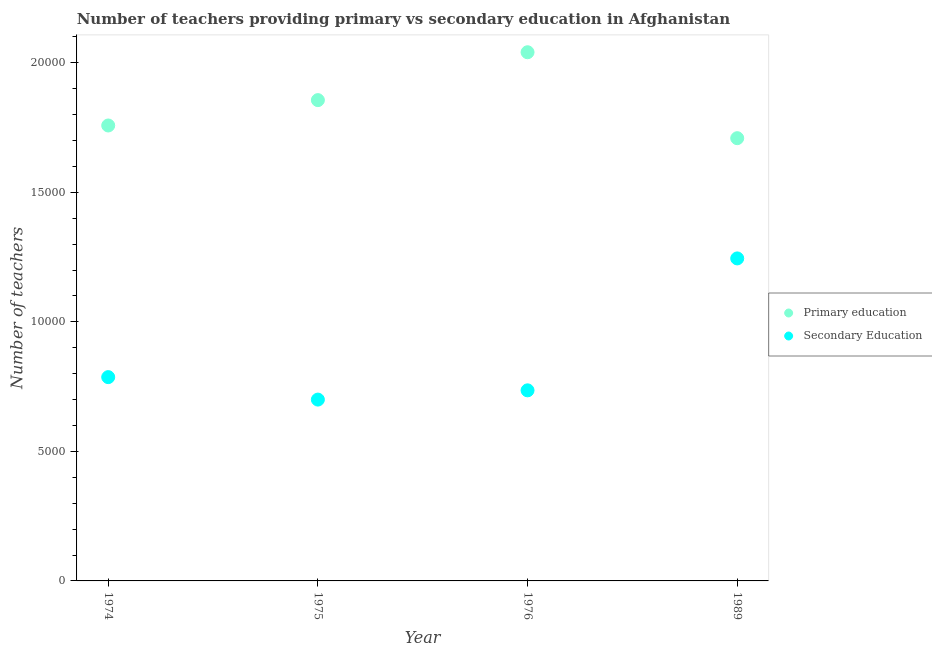Is the number of dotlines equal to the number of legend labels?
Ensure brevity in your answer.  Yes. What is the number of primary teachers in 1975?
Your answer should be very brief. 1.86e+04. Across all years, what is the maximum number of secondary teachers?
Offer a terse response. 1.24e+04. Across all years, what is the minimum number of secondary teachers?
Provide a succinct answer. 6999. What is the total number of secondary teachers in the graph?
Your answer should be compact. 3.47e+04. What is the difference between the number of secondary teachers in 1975 and that in 1989?
Ensure brevity in your answer.  -5449. What is the difference between the number of primary teachers in 1975 and the number of secondary teachers in 1976?
Your answer should be compact. 1.12e+04. What is the average number of primary teachers per year?
Ensure brevity in your answer.  1.84e+04. In the year 1989, what is the difference between the number of primary teachers and number of secondary teachers?
Provide a succinct answer. 4641. In how many years, is the number of secondary teachers greater than 17000?
Your answer should be compact. 0. What is the ratio of the number of primary teachers in 1974 to that in 1976?
Give a very brief answer. 0.86. Is the number of secondary teachers in 1975 less than that in 1989?
Give a very brief answer. Yes. What is the difference between the highest and the second highest number of secondary teachers?
Make the answer very short. 4582. What is the difference between the highest and the lowest number of primary teachers?
Provide a succinct answer. 3317. In how many years, is the number of secondary teachers greater than the average number of secondary teachers taken over all years?
Provide a succinct answer. 1. Is the sum of the number of secondary teachers in 1975 and 1989 greater than the maximum number of primary teachers across all years?
Keep it short and to the point. No. Does the number of primary teachers monotonically increase over the years?
Offer a very short reply. No. What is the difference between two consecutive major ticks on the Y-axis?
Your answer should be very brief. 5000. Are the values on the major ticks of Y-axis written in scientific E-notation?
Offer a very short reply. No. Does the graph contain grids?
Provide a succinct answer. No. How are the legend labels stacked?
Offer a very short reply. Vertical. What is the title of the graph?
Ensure brevity in your answer.  Number of teachers providing primary vs secondary education in Afghanistan. What is the label or title of the Y-axis?
Offer a very short reply. Number of teachers. What is the Number of teachers of Primary education in 1974?
Provide a short and direct response. 1.76e+04. What is the Number of teachers in Secondary Education in 1974?
Give a very brief answer. 7866. What is the Number of teachers in Primary education in 1975?
Give a very brief answer. 1.86e+04. What is the Number of teachers of Secondary Education in 1975?
Provide a succinct answer. 6999. What is the Number of teachers in Primary education in 1976?
Offer a terse response. 2.04e+04. What is the Number of teachers in Secondary Education in 1976?
Provide a succinct answer. 7356. What is the Number of teachers of Primary education in 1989?
Give a very brief answer. 1.71e+04. What is the Number of teachers of Secondary Education in 1989?
Your response must be concise. 1.24e+04. Across all years, what is the maximum Number of teachers of Primary education?
Offer a terse response. 2.04e+04. Across all years, what is the maximum Number of teachers of Secondary Education?
Your response must be concise. 1.24e+04. Across all years, what is the minimum Number of teachers in Primary education?
Keep it short and to the point. 1.71e+04. Across all years, what is the minimum Number of teachers in Secondary Education?
Give a very brief answer. 6999. What is the total Number of teachers in Primary education in the graph?
Provide a succinct answer. 7.36e+04. What is the total Number of teachers of Secondary Education in the graph?
Your answer should be compact. 3.47e+04. What is the difference between the Number of teachers in Primary education in 1974 and that in 1975?
Your answer should be compact. -979. What is the difference between the Number of teachers of Secondary Education in 1974 and that in 1975?
Ensure brevity in your answer.  867. What is the difference between the Number of teachers in Primary education in 1974 and that in 1976?
Your answer should be very brief. -2827. What is the difference between the Number of teachers of Secondary Education in 1974 and that in 1976?
Make the answer very short. 510. What is the difference between the Number of teachers of Primary education in 1974 and that in 1989?
Make the answer very short. 490. What is the difference between the Number of teachers in Secondary Education in 1974 and that in 1989?
Give a very brief answer. -4582. What is the difference between the Number of teachers in Primary education in 1975 and that in 1976?
Provide a short and direct response. -1848. What is the difference between the Number of teachers of Secondary Education in 1975 and that in 1976?
Keep it short and to the point. -357. What is the difference between the Number of teachers of Primary education in 1975 and that in 1989?
Keep it short and to the point. 1469. What is the difference between the Number of teachers of Secondary Education in 1975 and that in 1989?
Provide a short and direct response. -5449. What is the difference between the Number of teachers of Primary education in 1976 and that in 1989?
Keep it short and to the point. 3317. What is the difference between the Number of teachers in Secondary Education in 1976 and that in 1989?
Offer a terse response. -5092. What is the difference between the Number of teachers of Primary education in 1974 and the Number of teachers of Secondary Education in 1975?
Make the answer very short. 1.06e+04. What is the difference between the Number of teachers in Primary education in 1974 and the Number of teachers in Secondary Education in 1976?
Your answer should be very brief. 1.02e+04. What is the difference between the Number of teachers in Primary education in 1974 and the Number of teachers in Secondary Education in 1989?
Your response must be concise. 5131. What is the difference between the Number of teachers in Primary education in 1975 and the Number of teachers in Secondary Education in 1976?
Your response must be concise. 1.12e+04. What is the difference between the Number of teachers in Primary education in 1975 and the Number of teachers in Secondary Education in 1989?
Your answer should be compact. 6110. What is the difference between the Number of teachers in Primary education in 1976 and the Number of teachers in Secondary Education in 1989?
Give a very brief answer. 7958. What is the average Number of teachers of Primary education per year?
Offer a terse response. 1.84e+04. What is the average Number of teachers in Secondary Education per year?
Make the answer very short. 8667.25. In the year 1974, what is the difference between the Number of teachers of Primary education and Number of teachers of Secondary Education?
Provide a short and direct response. 9713. In the year 1975, what is the difference between the Number of teachers of Primary education and Number of teachers of Secondary Education?
Keep it short and to the point. 1.16e+04. In the year 1976, what is the difference between the Number of teachers in Primary education and Number of teachers in Secondary Education?
Offer a very short reply. 1.30e+04. In the year 1989, what is the difference between the Number of teachers of Primary education and Number of teachers of Secondary Education?
Provide a succinct answer. 4641. What is the ratio of the Number of teachers of Primary education in 1974 to that in 1975?
Offer a very short reply. 0.95. What is the ratio of the Number of teachers of Secondary Education in 1974 to that in 1975?
Your answer should be very brief. 1.12. What is the ratio of the Number of teachers of Primary education in 1974 to that in 1976?
Your response must be concise. 0.86. What is the ratio of the Number of teachers in Secondary Education in 1974 to that in 1976?
Your answer should be very brief. 1.07. What is the ratio of the Number of teachers of Primary education in 1974 to that in 1989?
Offer a terse response. 1.03. What is the ratio of the Number of teachers in Secondary Education in 1974 to that in 1989?
Provide a short and direct response. 0.63. What is the ratio of the Number of teachers of Primary education in 1975 to that in 1976?
Offer a terse response. 0.91. What is the ratio of the Number of teachers of Secondary Education in 1975 to that in 1976?
Keep it short and to the point. 0.95. What is the ratio of the Number of teachers in Primary education in 1975 to that in 1989?
Keep it short and to the point. 1.09. What is the ratio of the Number of teachers of Secondary Education in 1975 to that in 1989?
Keep it short and to the point. 0.56. What is the ratio of the Number of teachers of Primary education in 1976 to that in 1989?
Your answer should be compact. 1.19. What is the ratio of the Number of teachers in Secondary Education in 1976 to that in 1989?
Make the answer very short. 0.59. What is the difference between the highest and the second highest Number of teachers of Primary education?
Keep it short and to the point. 1848. What is the difference between the highest and the second highest Number of teachers of Secondary Education?
Make the answer very short. 4582. What is the difference between the highest and the lowest Number of teachers in Primary education?
Provide a short and direct response. 3317. What is the difference between the highest and the lowest Number of teachers of Secondary Education?
Give a very brief answer. 5449. 